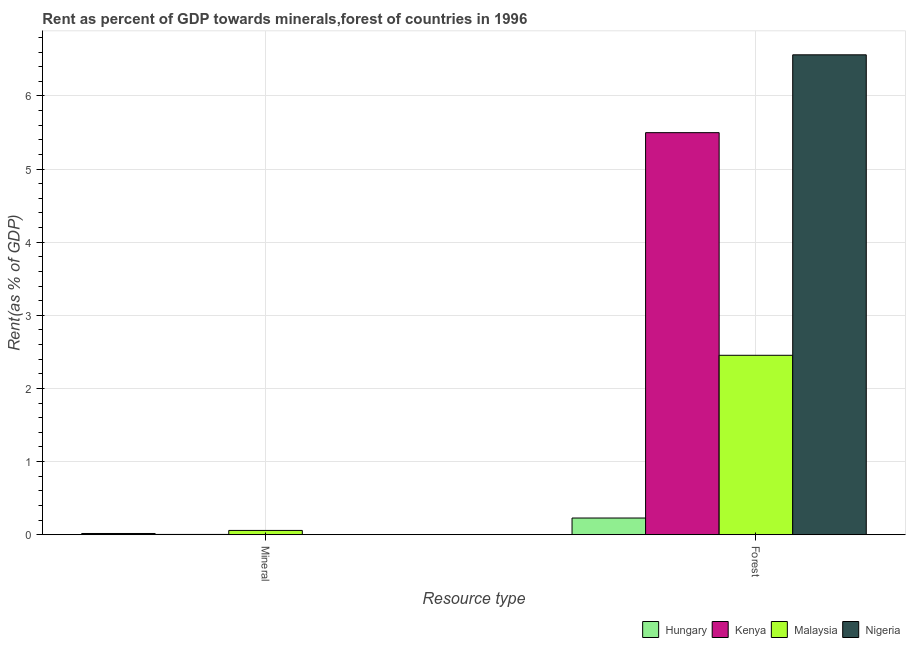How many different coloured bars are there?
Ensure brevity in your answer.  4. How many groups of bars are there?
Give a very brief answer. 2. Are the number of bars per tick equal to the number of legend labels?
Give a very brief answer. Yes. Are the number of bars on each tick of the X-axis equal?
Offer a terse response. Yes. How many bars are there on the 2nd tick from the left?
Keep it short and to the point. 4. What is the label of the 2nd group of bars from the left?
Give a very brief answer. Forest. What is the forest rent in Nigeria?
Your response must be concise. 6.56. Across all countries, what is the maximum mineral rent?
Offer a terse response. 0.06. Across all countries, what is the minimum mineral rent?
Offer a very short reply. 0. In which country was the forest rent maximum?
Keep it short and to the point. Nigeria. In which country was the mineral rent minimum?
Offer a very short reply. Nigeria. What is the total forest rent in the graph?
Provide a succinct answer. 14.74. What is the difference between the forest rent in Hungary and that in Nigeria?
Provide a short and direct response. -6.33. What is the difference between the forest rent in Nigeria and the mineral rent in Hungary?
Your answer should be very brief. 6.55. What is the average forest rent per country?
Give a very brief answer. 3.69. What is the difference between the forest rent and mineral rent in Malaysia?
Make the answer very short. 2.4. In how many countries, is the mineral rent greater than 6 %?
Offer a very short reply. 0. What is the ratio of the forest rent in Hungary to that in Malaysia?
Your answer should be very brief. 0.09. Is the mineral rent in Nigeria less than that in Hungary?
Ensure brevity in your answer.  Yes. What does the 1st bar from the left in Mineral represents?
Your answer should be very brief. Hungary. What does the 4th bar from the right in Mineral represents?
Offer a terse response. Hungary. How many bars are there?
Provide a succinct answer. 8. Are the values on the major ticks of Y-axis written in scientific E-notation?
Give a very brief answer. No. Does the graph contain grids?
Ensure brevity in your answer.  Yes. How are the legend labels stacked?
Provide a short and direct response. Horizontal. What is the title of the graph?
Your response must be concise. Rent as percent of GDP towards minerals,forest of countries in 1996. Does "Lesotho" appear as one of the legend labels in the graph?
Make the answer very short. No. What is the label or title of the X-axis?
Offer a terse response. Resource type. What is the label or title of the Y-axis?
Your response must be concise. Rent(as % of GDP). What is the Rent(as % of GDP) of Hungary in Mineral?
Keep it short and to the point. 0.02. What is the Rent(as % of GDP) of Kenya in Mineral?
Ensure brevity in your answer.  0. What is the Rent(as % of GDP) in Malaysia in Mineral?
Your response must be concise. 0.06. What is the Rent(as % of GDP) in Nigeria in Mineral?
Offer a very short reply. 0. What is the Rent(as % of GDP) of Hungary in Forest?
Your answer should be compact. 0.23. What is the Rent(as % of GDP) in Kenya in Forest?
Make the answer very short. 5.5. What is the Rent(as % of GDP) in Malaysia in Forest?
Provide a succinct answer. 2.45. What is the Rent(as % of GDP) of Nigeria in Forest?
Offer a very short reply. 6.56. Across all Resource type, what is the maximum Rent(as % of GDP) in Hungary?
Offer a terse response. 0.23. Across all Resource type, what is the maximum Rent(as % of GDP) of Kenya?
Keep it short and to the point. 5.5. Across all Resource type, what is the maximum Rent(as % of GDP) in Malaysia?
Offer a terse response. 2.45. Across all Resource type, what is the maximum Rent(as % of GDP) in Nigeria?
Provide a short and direct response. 6.56. Across all Resource type, what is the minimum Rent(as % of GDP) of Hungary?
Offer a very short reply. 0.02. Across all Resource type, what is the minimum Rent(as % of GDP) in Kenya?
Give a very brief answer. 0. Across all Resource type, what is the minimum Rent(as % of GDP) in Malaysia?
Offer a terse response. 0.06. Across all Resource type, what is the minimum Rent(as % of GDP) in Nigeria?
Offer a very short reply. 0. What is the total Rent(as % of GDP) in Hungary in the graph?
Your response must be concise. 0.24. What is the total Rent(as % of GDP) of Kenya in the graph?
Keep it short and to the point. 5.5. What is the total Rent(as % of GDP) in Malaysia in the graph?
Keep it short and to the point. 2.51. What is the total Rent(as % of GDP) of Nigeria in the graph?
Ensure brevity in your answer.  6.56. What is the difference between the Rent(as % of GDP) of Hungary in Mineral and that in Forest?
Provide a succinct answer. -0.21. What is the difference between the Rent(as % of GDP) of Kenya in Mineral and that in Forest?
Your answer should be very brief. -5.49. What is the difference between the Rent(as % of GDP) of Malaysia in Mineral and that in Forest?
Provide a succinct answer. -2.4. What is the difference between the Rent(as % of GDP) of Nigeria in Mineral and that in Forest?
Your response must be concise. -6.56. What is the difference between the Rent(as % of GDP) of Hungary in Mineral and the Rent(as % of GDP) of Kenya in Forest?
Your answer should be compact. -5.48. What is the difference between the Rent(as % of GDP) of Hungary in Mineral and the Rent(as % of GDP) of Malaysia in Forest?
Your answer should be very brief. -2.44. What is the difference between the Rent(as % of GDP) in Hungary in Mineral and the Rent(as % of GDP) in Nigeria in Forest?
Your answer should be very brief. -6.55. What is the difference between the Rent(as % of GDP) of Kenya in Mineral and the Rent(as % of GDP) of Malaysia in Forest?
Provide a succinct answer. -2.45. What is the difference between the Rent(as % of GDP) in Kenya in Mineral and the Rent(as % of GDP) in Nigeria in Forest?
Provide a short and direct response. -6.56. What is the difference between the Rent(as % of GDP) in Malaysia in Mineral and the Rent(as % of GDP) in Nigeria in Forest?
Give a very brief answer. -6.5. What is the average Rent(as % of GDP) in Hungary per Resource type?
Your answer should be very brief. 0.12. What is the average Rent(as % of GDP) of Kenya per Resource type?
Give a very brief answer. 2.75. What is the average Rent(as % of GDP) in Malaysia per Resource type?
Your answer should be very brief. 1.26. What is the average Rent(as % of GDP) in Nigeria per Resource type?
Offer a very short reply. 3.28. What is the difference between the Rent(as % of GDP) in Hungary and Rent(as % of GDP) in Kenya in Mineral?
Ensure brevity in your answer.  0.01. What is the difference between the Rent(as % of GDP) of Hungary and Rent(as % of GDP) of Malaysia in Mineral?
Ensure brevity in your answer.  -0.04. What is the difference between the Rent(as % of GDP) in Hungary and Rent(as % of GDP) in Nigeria in Mineral?
Provide a short and direct response. 0.02. What is the difference between the Rent(as % of GDP) in Kenya and Rent(as % of GDP) in Malaysia in Mineral?
Offer a very short reply. -0.05. What is the difference between the Rent(as % of GDP) in Kenya and Rent(as % of GDP) in Nigeria in Mineral?
Ensure brevity in your answer.  0. What is the difference between the Rent(as % of GDP) in Malaysia and Rent(as % of GDP) in Nigeria in Mineral?
Your answer should be very brief. 0.06. What is the difference between the Rent(as % of GDP) of Hungary and Rent(as % of GDP) of Kenya in Forest?
Your answer should be very brief. -5.27. What is the difference between the Rent(as % of GDP) in Hungary and Rent(as % of GDP) in Malaysia in Forest?
Offer a very short reply. -2.23. What is the difference between the Rent(as % of GDP) of Hungary and Rent(as % of GDP) of Nigeria in Forest?
Offer a very short reply. -6.33. What is the difference between the Rent(as % of GDP) of Kenya and Rent(as % of GDP) of Malaysia in Forest?
Keep it short and to the point. 3.04. What is the difference between the Rent(as % of GDP) of Kenya and Rent(as % of GDP) of Nigeria in Forest?
Your response must be concise. -1.06. What is the difference between the Rent(as % of GDP) in Malaysia and Rent(as % of GDP) in Nigeria in Forest?
Offer a terse response. -4.11. What is the ratio of the Rent(as % of GDP) of Hungary in Mineral to that in Forest?
Ensure brevity in your answer.  0.07. What is the ratio of the Rent(as % of GDP) of Kenya in Mineral to that in Forest?
Your answer should be compact. 0. What is the ratio of the Rent(as % of GDP) in Malaysia in Mineral to that in Forest?
Provide a short and direct response. 0.02. What is the ratio of the Rent(as % of GDP) in Nigeria in Mineral to that in Forest?
Make the answer very short. 0. What is the difference between the highest and the second highest Rent(as % of GDP) of Hungary?
Keep it short and to the point. 0.21. What is the difference between the highest and the second highest Rent(as % of GDP) of Kenya?
Make the answer very short. 5.49. What is the difference between the highest and the second highest Rent(as % of GDP) of Malaysia?
Offer a terse response. 2.4. What is the difference between the highest and the second highest Rent(as % of GDP) in Nigeria?
Your answer should be compact. 6.56. What is the difference between the highest and the lowest Rent(as % of GDP) in Hungary?
Your response must be concise. 0.21. What is the difference between the highest and the lowest Rent(as % of GDP) of Kenya?
Give a very brief answer. 5.49. What is the difference between the highest and the lowest Rent(as % of GDP) in Malaysia?
Your answer should be compact. 2.4. What is the difference between the highest and the lowest Rent(as % of GDP) of Nigeria?
Offer a terse response. 6.56. 